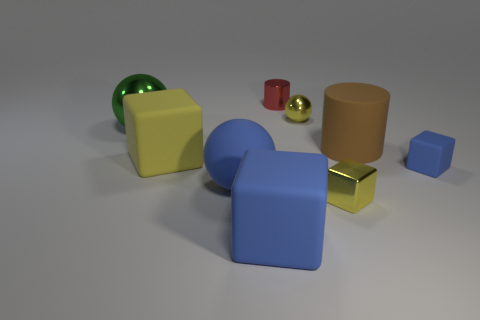Add 1 yellow things. How many objects exist? 10 Subtract all cubes. How many objects are left? 5 Add 2 small shiny cylinders. How many small shiny cylinders are left? 3 Add 2 blue matte objects. How many blue matte objects exist? 5 Subtract 1 green balls. How many objects are left? 8 Subtract all gray metal cubes. Subtract all large blue matte spheres. How many objects are left? 8 